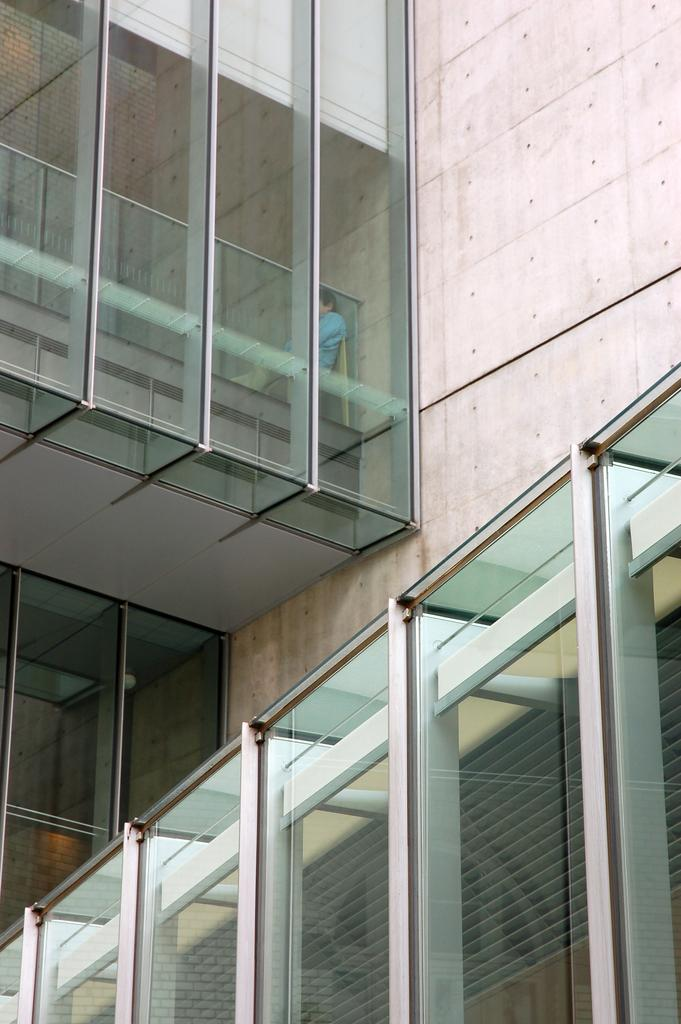What type of structure is visible in the image? There is a building in the image. What is located near the building? There is a wall in the image. Can you describe the presence of a person in the image? There is a person inside the building. What type of breakfast is the doll eating in the image? There is no doll or breakfast present in the image. What mark can be seen on the wall in the image? There is no mark visible on the wall in the image. 